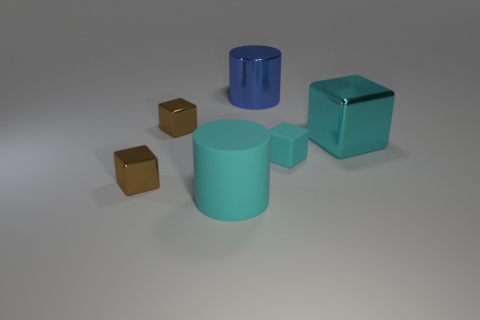What is the material of the cylinder that is the same size as the blue shiny thing?
Provide a succinct answer. Rubber. Do the big thing that is on the left side of the blue metal cylinder and the cylinder that is behind the cyan matte cylinder have the same material?
Provide a short and direct response. No. There is a blue thing that is the same size as the cyan cylinder; what shape is it?
Your response must be concise. Cylinder. How many other things are there of the same color as the matte cylinder?
Your answer should be very brief. 2. There is a object that is on the right side of the small cyan rubber thing; what is its color?
Make the answer very short. Cyan. How many other objects are there of the same material as the cyan cylinder?
Your response must be concise. 1. Is the number of small cubes that are to the left of the cyan rubber cylinder greater than the number of blue objects on the right side of the shiny cylinder?
Your response must be concise. Yes. What number of matte blocks are in front of the small cyan thing?
Your response must be concise. 0. Is the big blue object made of the same material as the large cube that is on the right side of the large blue metallic thing?
Your answer should be compact. Yes. Is the material of the blue cylinder the same as the small cyan thing?
Make the answer very short. No. 